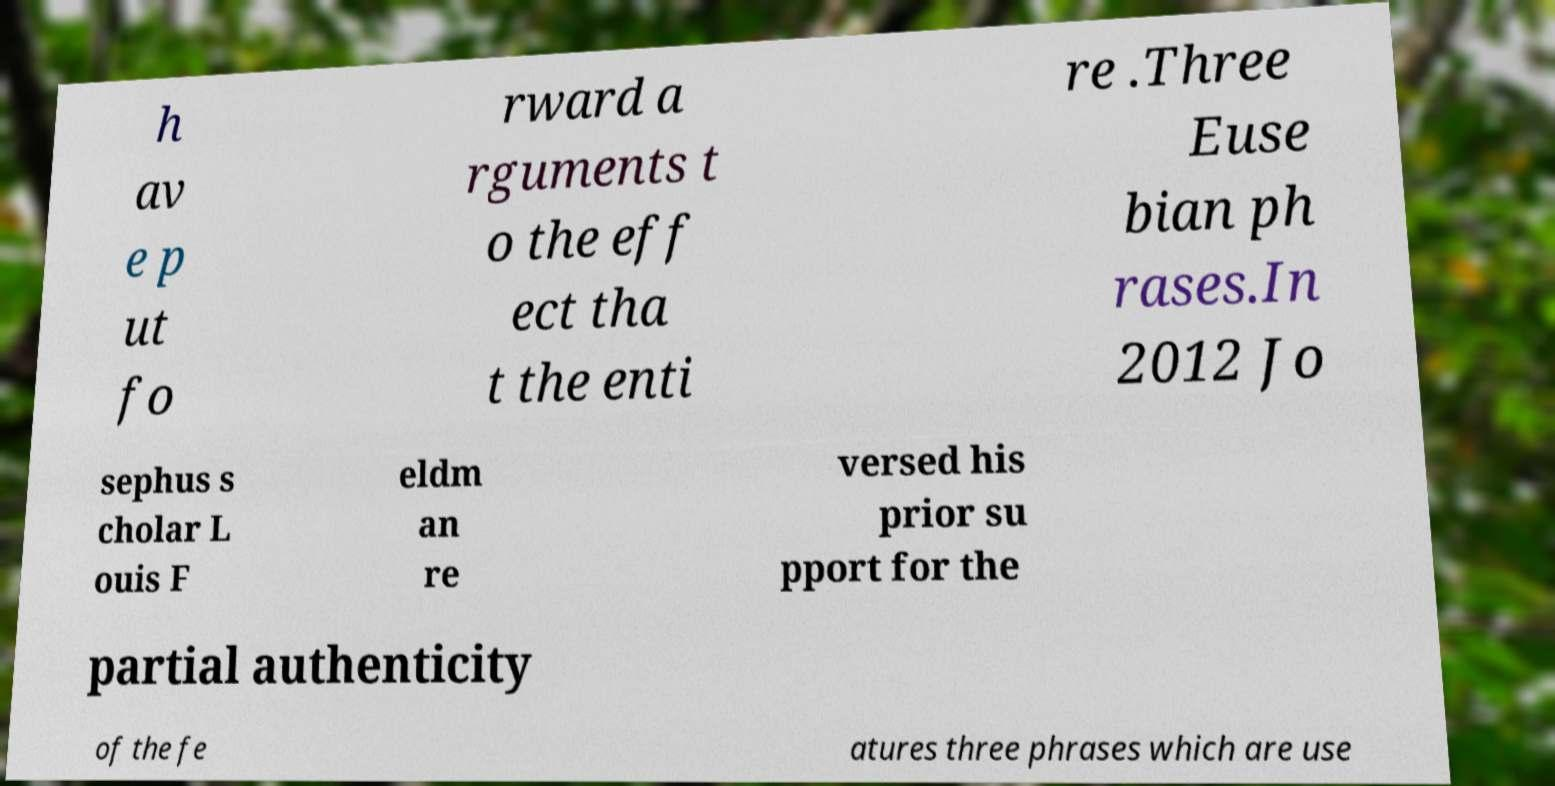What messages or text are displayed in this image? I need them in a readable, typed format. h av e p ut fo rward a rguments t o the eff ect tha t the enti re .Three Euse bian ph rases.In 2012 Jo sephus s cholar L ouis F eldm an re versed his prior su pport for the partial authenticity of the fe atures three phrases which are use 